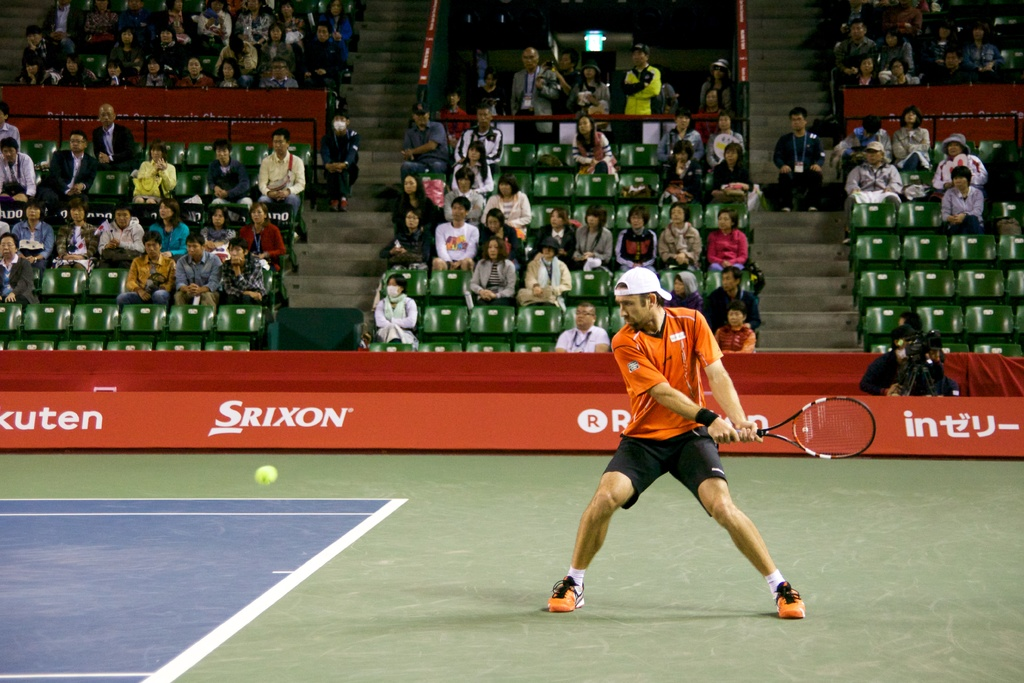Describe the atmosphere of the tennis court as seen in the image. The atmosphere in the tennis court appears charged and intense, with a focused crowd watching quietly, creating a setting that underscores the high stakes and competitive nature of the match. 